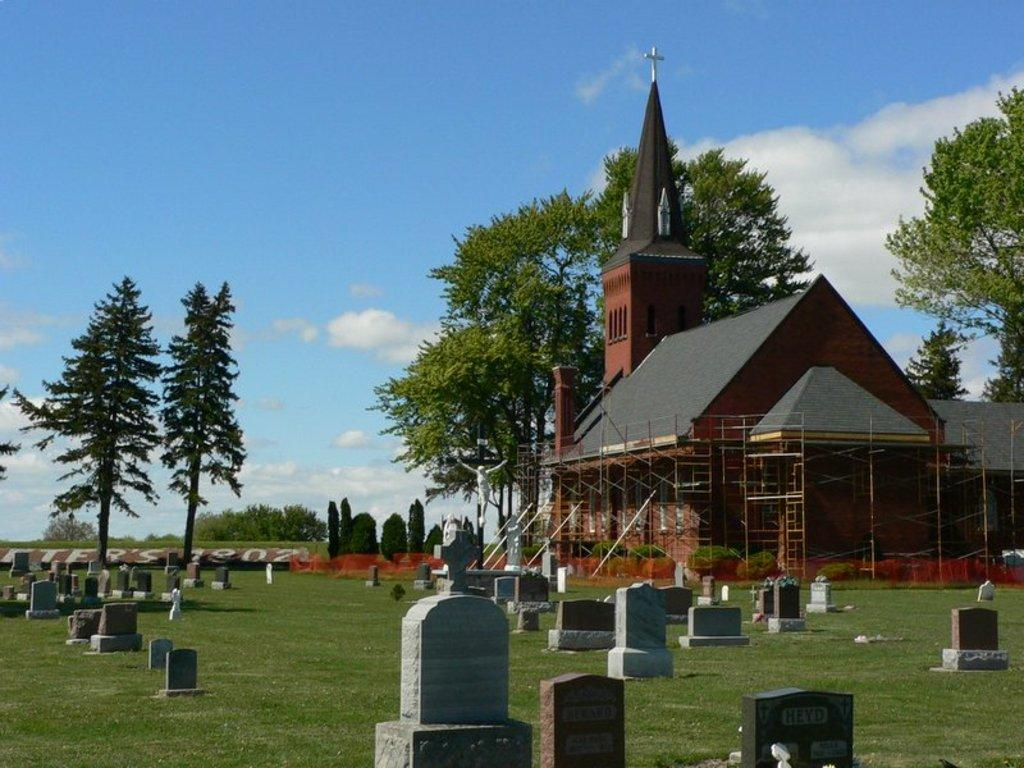What type of structures are present in the image? There are memorial stones and a house in the image. What type of vegetation can be seen in the image? There are trees, plants, and grass in the image. What is visible in the background of the image? The sky is cloudy in the background of the image. How many quarters can be seen on the tiger in the image? There is no tiger or quarter present in the image. What type of account is mentioned in the image? There is no mention of an account in the image. 